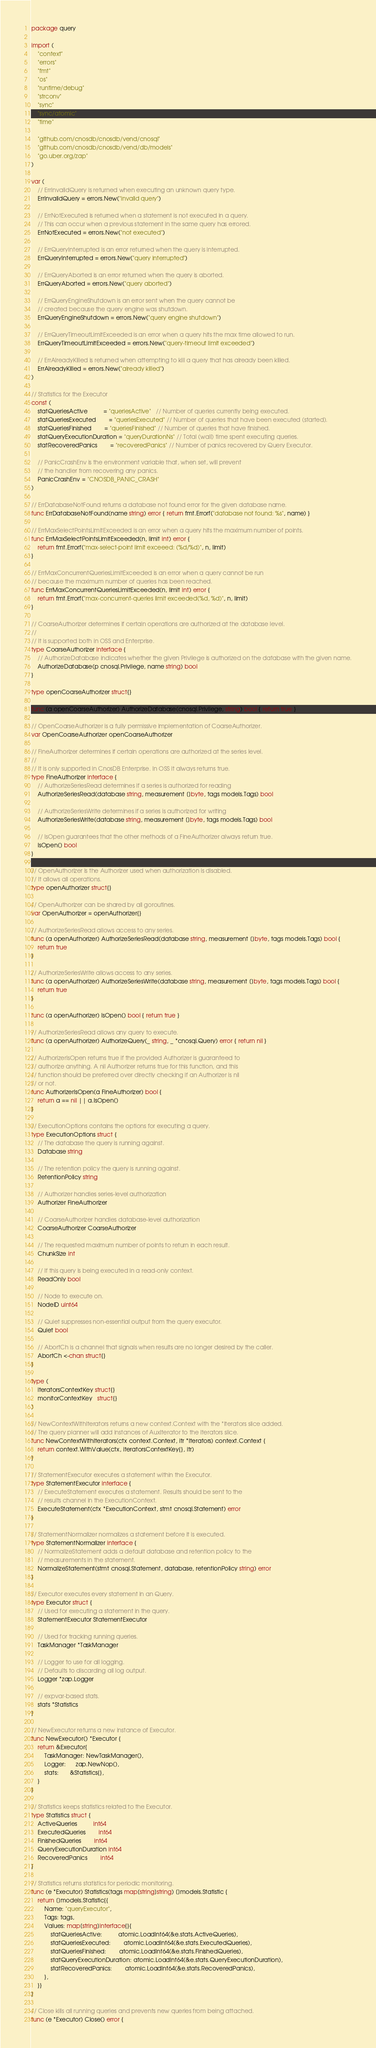Convert code to text. <code><loc_0><loc_0><loc_500><loc_500><_Go_>package query

import (
	"context"
	"errors"
	"fmt"
	"os"
	"runtime/debug"
	"strconv"
	"sync"
	"sync/atomic"
	"time"

	"github.com/cnosdb/cnosdb/vend/cnosql"
	"github.com/cnosdb/cnosdb/vend/db/models"
	"go.uber.org/zap"
)

var (
	// ErrInvalidQuery is returned when executing an unknown query type.
	ErrInvalidQuery = errors.New("invalid query")

	// ErrNotExecuted is returned when a statement is not executed in a query.
	// This can occur when a previous statement in the same query has errored.
	ErrNotExecuted = errors.New("not executed")

	// ErrQueryInterrupted is an error returned when the query is interrupted.
	ErrQueryInterrupted = errors.New("query interrupted")

	// ErrQueryAborted is an error returned when the query is aborted.
	ErrQueryAborted = errors.New("query aborted")

	// ErrQueryEngineShutdown is an error sent when the query cannot be
	// created because the query engine was shutdown.
	ErrQueryEngineShutdown = errors.New("query engine shutdown")

	// ErrQueryTimeoutLimitExceeded is an error when a query hits the max time allowed to run.
	ErrQueryTimeoutLimitExceeded = errors.New("query-timeout limit exceeded")

	// ErrAlreadyKilled is returned when attempting to kill a query that has already been killed.
	ErrAlreadyKilled = errors.New("already killed")
)

// Statistics for the Executor
const (
	statQueriesActive          = "queriesActive"   // Number of queries currently being executed.
	statQueriesExecuted        = "queriesExecuted" // Number of queries that have been executed (started).
	statQueriesFinished        = "queriesFinished" // Number of queries that have finished.
	statQueryExecutionDuration = "queryDurationNs" // Total (wall) time spent executing queries.
	statRecoveredPanics        = "recoveredPanics" // Number of panics recovered by Query Executor.

	// PanicCrashEnv is the environment variable that, when set, will prevent
	// the handler from recovering any panics.
	PanicCrashEnv = "CNOSDB_PANIC_CRASH"
)

// ErrDatabaseNotFound returns a database not found error for the given database name.
func ErrDatabaseNotFound(name string) error { return fmt.Errorf("database not found: %s", name) }

// ErrMaxSelectPointsLimitExceeded is an error when a query hits the maximum number of points.
func ErrMaxSelectPointsLimitExceeded(n, limit int) error {
	return fmt.Errorf("max-select-point limit exceeed: (%d/%d)", n, limit)
}

// ErrMaxConcurrentQueriesLimitExceeded is an error when a query cannot be run
// because the maximum number of queries has been reached.
func ErrMaxConcurrentQueriesLimitExceeded(n, limit int) error {
	return fmt.Errorf("max-concurrent-queries limit exceeded(%d, %d)", n, limit)
}

// CoarseAuthorizer determines if certain operations are authorized at the database level.
//
// It is supported both in OSS and Enterprise.
type CoarseAuthorizer interface {
	// AuthorizeDatabase indicates whether the given Privilege is authorized on the database with the given name.
	AuthorizeDatabase(p cnosql.Privilege, name string) bool
}

type openCoarseAuthorizer struct{}

func (a openCoarseAuthorizer) AuthorizeDatabase(cnosql.Privilege, string) bool { return true }

// OpenCoarseAuthorizer is a fully permissive implementation of CoarseAuthorizer.
var OpenCoarseAuthorizer openCoarseAuthorizer

// FineAuthorizer determines if certain operations are authorized at the series level.
//
// It is only supported in CnosDB Enterprise. In OSS it always returns true.
type FineAuthorizer interface {
	// AuthorizeSeriesRead determines if a series is authorized for reading
	AuthorizeSeriesRead(database string, measurement []byte, tags models.Tags) bool

	// AuthorizeSeriesWrite determines if a series is authorized for writing
	AuthorizeSeriesWrite(database string, measurement []byte, tags models.Tags) bool

	// IsOpen guarantees that the other methods of a FineAuthorizer always return true.
	IsOpen() bool
}

// OpenAuthorizer is the Authorizer used when authorization is disabled.
// It allows all operations.
type openAuthorizer struct{}

// OpenAuthorizer can be shared by all goroutines.
var OpenAuthorizer = openAuthorizer{}

// AuthorizeSeriesRead allows access to any series.
func (a openAuthorizer) AuthorizeSeriesRead(database string, measurement []byte, tags models.Tags) bool {
	return true
}

// AuthorizeSeriesWrite allows access to any series.
func (a openAuthorizer) AuthorizeSeriesWrite(database string, measurement []byte, tags models.Tags) bool {
	return true
}

func (a openAuthorizer) IsOpen() bool { return true }

// AuthorizeSeriesRead allows any query to execute.
func (a openAuthorizer) AuthorizeQuery(_ string, _ *cnosql.Query) error { return nil }

// AuthorizerIsOpen returns true if the provided Authorizer is guaranteed to
// authorize anything. A nil Authorizer returns true for this function, and this
// function should be preferred over directly checking if an Authorizer is nil
// or not.
func AuthorizerIsOpen(a FineAuthorizer) bool {
	return a == nil || a.IsOpen()
}

// ExecutionOptions contains the options for executing a query.
type ExecutionOptions struct {
	// The database the query is running against.
	Database string

	// The retention policy the query is running against.
	RetentionPolicy string

	// Authorizer handles series-level authorization
	Authorizer FineAuthorizer

	// CoarseAuthorizer handles database-level authorization
	CoarseAuthorizer CoarseAuthorizer

	// The requested maximum number of points to return in each result.
	ChunkSize int

	// If this query is being executed in a read-only context.
	ReadOnly bool

	// Node to execute on.
	NodeID uint64

	// Quiet suppresses non-essential output from the query executor.
	Quiet bool

	// AbortCh is a channel that signals when results are no longer desired by the caller.
	AbortCh <-chan struct{}
}

type (
	iteratorsContextKey struct{}
	monitorContextKey   struct{}
)

// NewContextWithIterators returns a new context.Context with the *Iterators slice added.
// The query planner will add instances of AuxIterator to the Iterators slice.
func NewContextWithIterators(ctx context.Context, itr *Iterators) context.Context {
	return context.WithValue(ctx, iteratorsContextKey{}, itr)
}

// StatementExecutor executes a statement within the Executor.
type StatementExecutor interface {
	// ExecuteStatement executes a statement. Results should be sent to the
	// results channel in the ExecutionContext.
	ExecuteStatement(ctx *ExecutionContext, stmt cnosql.Statement) error
}

// StatementNormalizer normalizes a statement before it is executed.
type StatementNormalizer interface {
	// NormalizeStatement adds a default database and retention policy to the
	// measurements in the statement.
	NormalizeStatement(stmt cnosql.Statement, database, retentionPolicy string) error
}

// Executor executes every statement in an Query.
type Executor struct {
	// Used for executing a statement in the query.
	StatementExecutor StatementExecutor

	// Used for tracking running queries.
	TaskManager *TaskManager

	// Logger to use for all logging.
	// Defaults to discarding all log output.
	Logger *zap.Logger

	// expvar-based stats.
	stats *Statistics
}

// NewExecutor returns a new instance of Executor.
func NewExecutor() *Executor {
	return &Executor{
		TaskManager: NewTaskManager(),
		Logger:      zap.NewNop(),
		stats:       &Statistics{},
	}
}

// Statistics keeps statistics related to the Executor.
type Statistics struct {
	ActiveQueries          int64
	ExecutedQueries        int64
	FinishedQueries        int64
	QueryExecutionDuration int64
	RecoveredPanics        int64
}

// Statistics returns statistics for periodic monitoring.
func (e *Executor) Statistics(tags map[string]string) []models.Statistic {
	return []models.Statistic{{
		Name: "queryExecutor",
		Tags: tags,
		Values: map[string]interface{}{
			statQueriesActive:          atomic.LoadInt64(&e.stats.ActiveQueries),
			statQueriesExecuted:        atomic.LoadInt64(&e.stats.ExecutedQueries),
			statQueriesFinished:        atomic.LoadInt64(&e.stats.FinishedQueries),
			statQueryExecutionDuration: atomic.LoadInt64(&e.stats.QueryExecutionDuration),
			statRecoveredPanics:        atomic.LoadInt64(&e.stats.RecoveredPanics),
		},
	}}
}

// Close kills all running queries and prevents new queries from being attached.
func (e *Executor) Close() error {</code> 